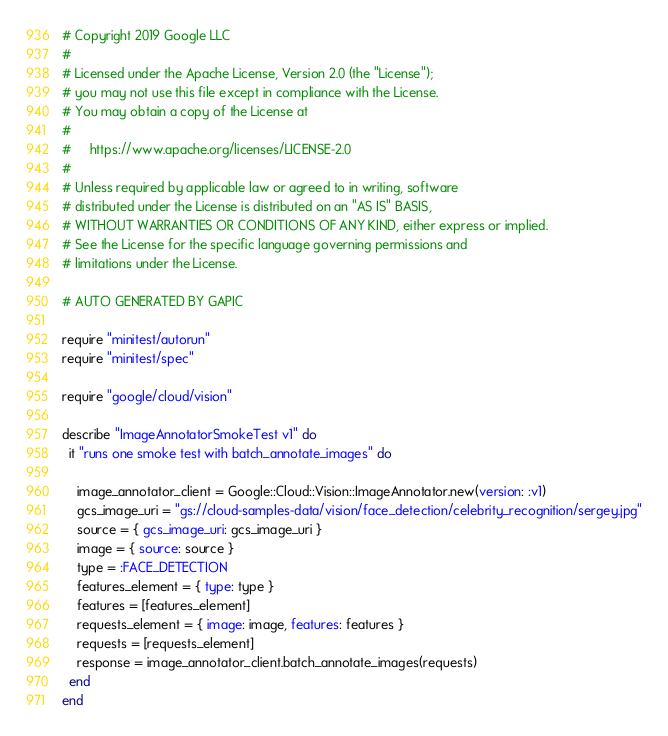<code> <loc_0><loc_0><loc_500><loc_500><_Ruby_># Copyright 2019 Google LLC
#
# Licensed under the Apache License, Version 2.0 (the "License");
# you may not use this file except in compliance with the License.
# You may obtain a copy of the License at
#
#     https://www.apache.org/licenses/LICENSE-2.0
#
# Unless required by applicable law or agreed to in writing, software
# distributed under the License is distributed on an "AS IS" BASIS,
# WITHOUT WARRANTIES OR CONDITIONS OF ANY KIND, either express or implied.
# See the License for the specific language governing permissions and
# limitations under the License.

# AUTO GENERATED BY GAPIC

require "minitest/autorun"
require "minitest/spec"

require "google/cloud/vision"

describe "ImageAnnotatorSmokeTest v1" do
  it "runs one smoke test with batch_annotate_images" do

    image_annotator_client = Google::Cloud::Vision::ImageAnnotator.new(version: :v1)
    gcs_image_uri = "gs://cloud-samples-data/vision/face_detection/celebrity_recognition/sergey.jpg"
    source = { gcs_image_uri: gcs_image_uri }
    image = { source: source }
    type = :FACE_DETECTION
    features_element = { type: type }
    features = [features_element]
    requests_element = { image: image, features: features }
    requests = [requests_element]
    response = image_annotator_client.batch_annotate_images(requests)
  end
end
</code> 